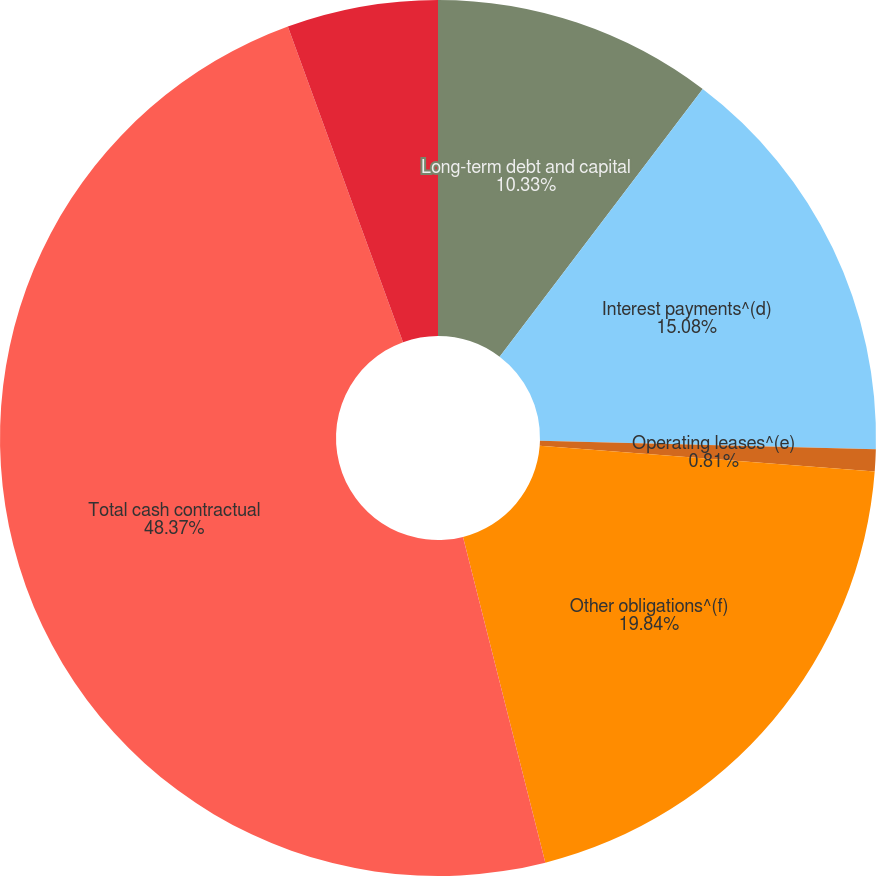Convert chart to OTSL. <chart><loc_0><loc_0><loc_500><loc_500><pie_chart><fcel>Long-term debt and capital<fcel>Interest payments^(d)<fcel>Operating leases^(e)<fcel>Other obligations^(f)<fcel>Total cash contractual<fcel>Interest payments<nl><fcel>10.33%<fcel>15.08%<fcel>0.81%<fcel>19.84%<fcel>48.37%<fcel>5.57%<nl></chart> 